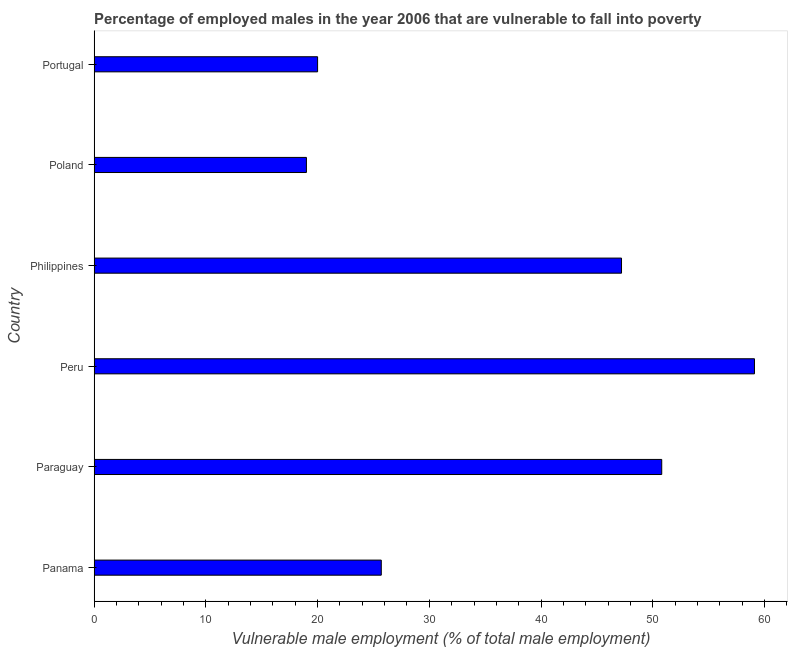Does the graph contain any zero values?
Keep it short and to the point. No. Does the graph contain grids?
Your answer should be compact. No. What is the title of the graph?
Ensure brevity in your answer.  Percentage of employed males in the year 2006 that are vulnerable to fall into poverty. What is the label or title of the X-axis?
Make the answer very short. Vulnerable male employment (% of total male employment). What is the label or title of the Y-axis?
Make the answer very short. Country. What is the percentage of employed males who are vulnerable to fall into poverty in Philippines?
Provide a succinct answer. 47.2. Across all countries, what is the maximum percentage of employed males who are vulnerable to fall into poverty?
Offer a terse response. 59.1. In which country was the percentage of employed males who are vulnerable to fall into poverty maximum?
Provide a succinct answer. Peru. In which country was the percentage of employed males who are vulnerable to fall into poverty minimum?
Offer a terse response. Poland. What is the sum of the percentage of employed males who are vulnerable to fall into poverty?
Your answer should be very brief. 221.8. What is the difference between the percentage of employed males who are vulnerable to fall into poverty in Philippines and Poland?
Your answer should be compact. 28.2. What is the average percentage of employed males who are vulnerable to fall into poverty per country?
Your answer should be very brief. 36.97. What is the median percentage of employed males who are vulnerable to fall into poverty?
Make the answer very short. 36.45. What is the ratio of the percentage of employed males who are vulnerable to fall into poverty in Panama to that in Poland?
Ensure brevity in your answer.  1.35. Is the percentage of employed males who are vulnerable to fall into poverty in Poland less than that in Portugal?
Keep it short and to the point. Yes. What is the difference between the highest and the second highest percentage of employed males who are vulnerable to fall into poverty?
Your response must be concise. 8.3. Is the sum of the percentage of employed males who are vulnerable to fall into poverty in Panama and Peru greater than the maximum percentage of employed males who are vulnerable to fall into poverty across all countries?
Keep it short and to the point. Yes. What is the difference between the highest and the lowest percentage of employed males who are vulnerable to fall into poverty?
Your response must be concise. 40.1. What is the difference between two consecutive major ticks on the X-axis?
Keep it short and to the point. 10. What is the Vulnerable male employment (% of total male employment) of Panama?
Provide a succinct answer. 25.7. What is the Vulnerable male employment (% of total male employment) of Paraguay?
Your response must be concise. 50.8. What is the Vulnerable male employment (% of total male employment) in Peru?
Make the answer very short. 59.1. What is the Vulnerable male employment (% of total male employment) in Philippines?
Provide a succinct answer. 47.2. What is the Vulnerable male employment (% of total male employment) in Poland?
Your response must be concise. 19. What is the Vulnerable male employment (% of total male employment) in Portugal?
Offer a terse response. 20. What is the difference between the Vulnerable male employment (% of total male employment) in Panama and Paraguay?
Provide a succinct answer. -25.1. What is the difference between the Vulnerable male employment (% of total male employment) in Panama and Peru?
Your response must be concise. -33.4. What is the difference between the Vulnerable male employment (% of total male employment) in Panama and Philippines?
Provide a succinct answer. -21.5. What is the difference between the Vulnerable male employment (% of total male employment) in Panama and Poland?
Make the answer very short. 6.7. What is the difference between the Vulnerable male employment (% of total male employment) in Paraguay and Poland?
Ensure brevity in your answer.  31.8. What is the difference between the Vulnerable male employment (% of total male employment) in Paraguay and Portugal?
Provide a short and direct response. 30.8. What is the difference between the Vulnerable male employment (% of total male employment) in Peru and Philippines?
Provide a succinct answer. 11.9. What is the difference between the Vulnerable male employment (% of total male employment) in Peru and Poland?
Your response must be concise. 40.1. What is the difference between the Vulnerable male employment (% of total male employment) in Peru and Portugal?
Make the answer very short. 39.1. What is the difference between the Vulnerable male employment (% of total male employment) in Philippines and Poland?
Offer a terse response. 28.2. What is the difference between the Vulnerable male employment (% of total male employment) in Philippines and Portugal?
Your response must be concise. 27.2. What is the difference between the Vulnerable male employment (% of total male employment) in Poland and Portugal?
Offer a very short reply. -1. What is the ratio of the Vulnerable male employment (% of total male employment) in Panama to that in Paraguay?
Offer a very short reply. 0.51. What is the ratio of the Vulnerable male employment (% of total male employment) in Panama to that in Peru?
Your answer should be very brief. 0.43. What is the ratio of the Vulnerable male employment (% of total male employment) in Panama to that in Philippines?
Your response must be concise. 0.54. What is the ratio of the Vulnerable male employment (% of total male employment) in Panama to that in Poland?
Give a very brief answer. 1.35. What is the ratio of the Vulnerable male employment (% of total male employment) in Panama to that in Portugal?
Offer a very short reply. 1.28. What is the ratio of the Vulnerable male employment (% of total male employment) in Paraguay to that in Peru?
Provide a short and direct response. 0.86. What is the ratio of the Vulnerable male employment (% of total male employment) in Paraguay to that in Philippines?
Ensure brevity in your answer.  1.08. What is the ratio of the Vulnerable male employment (% of total male employment) in Paraguay to that in Poland?
Your answer should be compact. 2.67. What is the ratio of the Vulnerable male employment (% of total male employment) in Paraguay to that in Portugal?
Give a very brief answer. 2.54. What is the ratio of the Vulnerable male employment (% of total male employment) in Peru to that in Philippines?
Provide a succinct answer. 1.25. What is the ratio of the Vulnerable male employment (% of total male employment) in Peru to that in Poland?
Provide a short and direct response. 3.11. What is the ratio of the Vulnerable male employment (% of total male employment) in Peru to that in Portugal?
Offer a terse response. 2.96. What is the ratio of the Vulnerable male employment (% of total male employment) in Philippines to that in Poland?
Provide a succinct answer. 2.48. What is the ratio of the Vulnerable male employment (% of total male employment) in Philippines to that in Portugal?
Keep it short and to the point. 2.36. What is the ratio of the Vulnerable male employment (% of total male employment) in Poland to that in Portugal?
Your response must be concise. 0.95. 